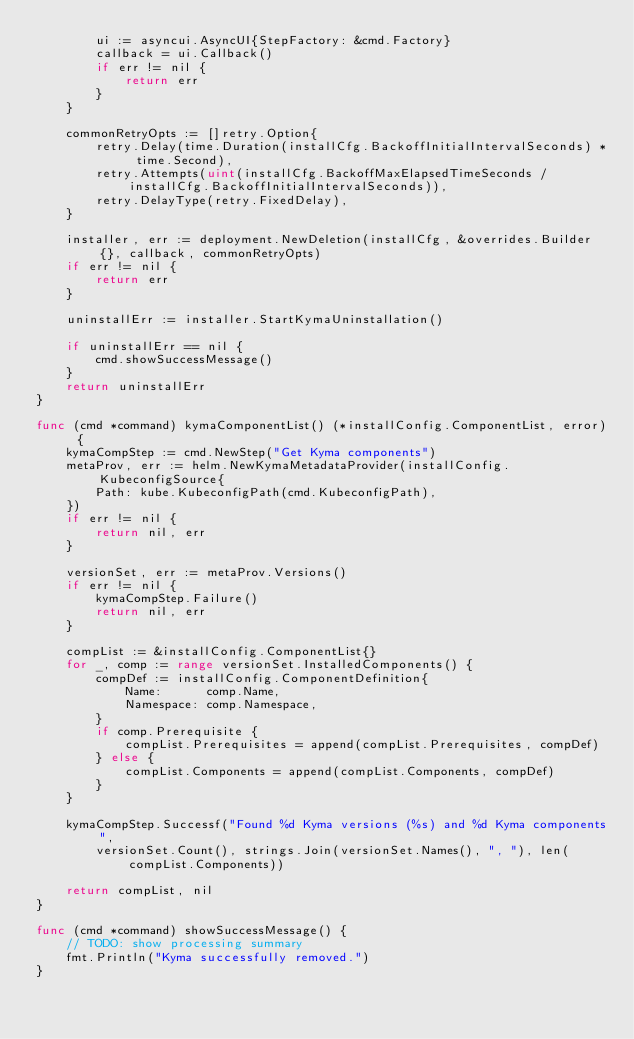<code> <loc_0><loc_0><loc_500><loc_500><_Go_>		ui := asyncui.AsyncUI{StepFactory: &cmd.Factory}
		callback = ui.Callback()
		if err != nil {
			return err
		}
	}

	commonRetryOpts := []retry.Option{
		retry.Delay(time.Duration(installCfg.BackoffInitialIntervalSeconds) * time.Second),
		retry.Attempts(uint(installCfg.BackoffMaxElapsedTimeSeconds / installCfg.BackoffInitialIntervalSeconds)),
		retry.DelayType(retry.FixedDelay),
	}

	installer, err := deployment.NewDeletion(installCfg, &overrides.Builder{}, callback, commonRetryOpts)
	if err != nil {
		return err
	}

	uninstallErr := installer.StartKymaUninstallation()

	if uninstallErr == nil {
		cmd.showSuccessMessage()
	}
	return uninstallErr
}

func (cmd *command) kymaComponentList() (*installConfig.ComponentList, error) {
	kymaCompStep := cmd.NewStep("Get Kyma components")
	metaProv, err := helm.NewKymaMetadataProvider(installConfig.KubeconfigSource{
		Path: kube.KubeconfigPath(cmd.KubeconfigPath),
	})
	if err != nil {
		return nil, err
	}

	versionSet, err := metaProv.Versions()
	if err != nil {
		kymaCompStep.Failure()
		return nil, err
	}

	compList := &installConfig.ComponentList{}
	for _, comp := range versionSet.InstalledComponents() {
		compDef := installConfig.ComponentDefinition{
			Name:      comp.Name,
			Namespace: comp.Namespace,
		}
		if comp.Prerequisite {
			compList.Prerequisites = append(compList.Prerequisites, compDef)
		} else {
			compList.Components = append(compList.Components, compDef)
		}
	}

	kymaCompStep.Successf("Found %d Kyma versions (%s) and %d Kyma components",
		versionSet.Count(), strings.Join(versionSet.Names(), ", "), len(compList.Components))

	return compList, nil
}

func (cmd *command) showSuccessMessage() {
	// TODO: show processing summary
	fmt.Println("Kyma successfully removed.")
}
</code> 